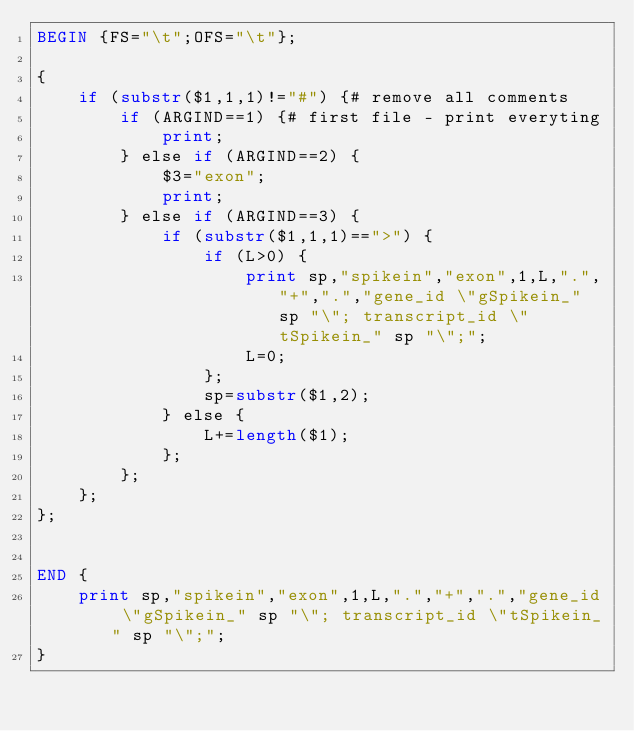Convert code to text. <code><loc_0><loc_0><loc_500><loc_500><_Awk_>BEGIN {FS="\t";OFS="\t"};

{
    if (substr($1,1,1)!="#") {# remove all comments
        if (ARGIND==1) {# first file - print everyting
            print;
        } else if (ARGIND==2) {
            $3="exon"; 
            print;
        } else if (ARGIND==3) {
            if (substr($1,1,1)==">") {
                if (L>0) {
                    print sp,"spikein","exon",1,L,".","+",".","gene_id \"gSpikein_" sp "\"; transcript_id \"tSpikein_" sp "\";";
                    L=0;
                };
                sp=substr($1,2);
            } else {
                L+=length($1);
            };
        };
    };
};


END {
    print sp,"spikein","exon",1,L,".","+",".","gene_id \"gSpikein_" sp "\"; transcript_id \"tSpikein_" sp "\";";
}
</code> 